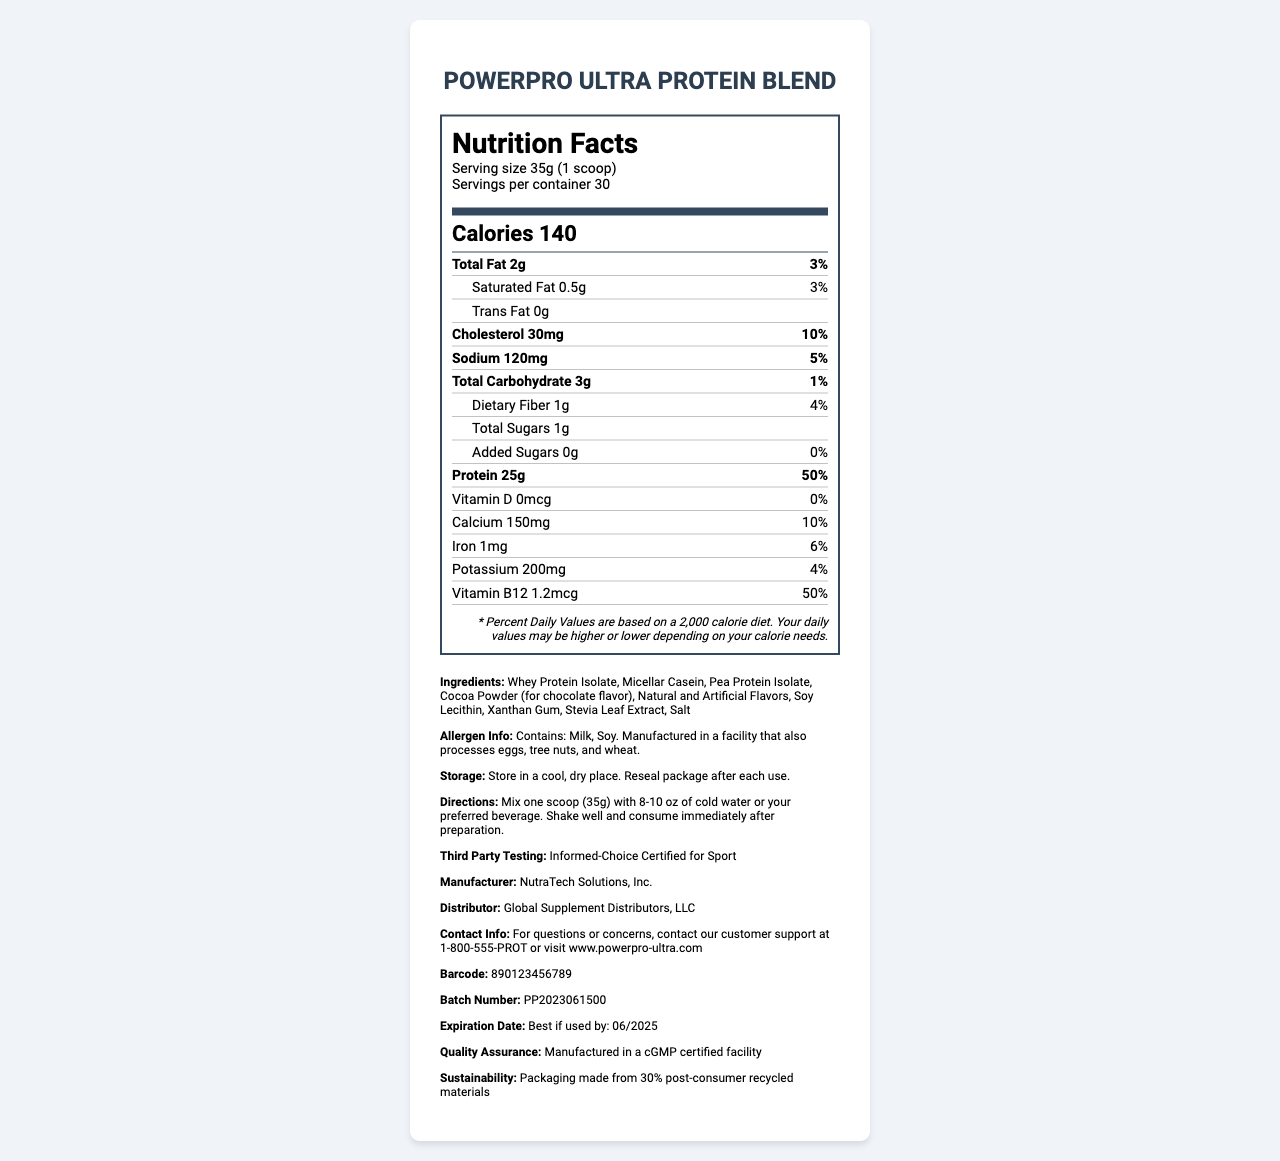what is the serving size? The serving size is specified as 35g (1 scoop) in the document.
Answer: 35g (1 scoop) how many calories are in one serving? The number of calories in one serving is listed as 140 in the document.
Answer: 140 how much protein does one serving contain? The amount of protein in one serving is specified as 25g in the document.
Answer: 25g what is the amount of total fat per serving? The amount of total fat per serving is listed as 2g in the document.
Answer: 2g what is the daily percentage value of sodium in one serving? The daily percentage value of sodium per serving is listed as 5% in the document.
Answer: 5% Which of the following is NOT an ingredient in the product? 
A. Cocoa Powder 
B. Stevia Leaf Extract 
C. Sucralose 
D. Xanthan Gum The listed ingredients are: Whey Protein Isolate, Micellar Casein, Pea Protein Isolate, Cocoa Powder, Natural and Artificial Flavors, Soy Lecithin, Xanthan Gum, Stevia Leaf Extract, and Salt.
Answer: C. Sucralose How is the product certified for quality assurance? 
I. cGMP certified facility 
II. Informed-Choice Certified for Sport 
III. FDA approved The document mentions both "Manufactured in a cGMP certified facility" and "Informed-Choice Certified for Sport."
Answer: I and II. does this product contain iron? The document mentions that the product contains 1mg of iron.
Answer: Yes summarize the key information from the nutrition facts label The summary includes the nutritional details and other product-related information, like ingredients, allergen info, storage instructions, and certifications.
Answer: The document provides detailed nutritional information about PowerPro Ultra Protein Blend, including serving size (35g), calories (140 per serving), and various macronutrients and micronutrients. It also lists ingredients, allergen information, storage instructions, and certifications. how is the product flavored? The document lists Natural and Artificial Flavors and Cocoa Powder as flavoring agents.
Answer: Natural and Artificial Flavors, Cocoa Powder (for chocolate flavor) what is the expiration date for this product? The expiration date listed in the document is "Best if used by: 06/2025."
Answer: Best if used by: 06/2025 what should customers do if they have questions about the product? The document provides customer support contact information for questions or concerns.
Answer: Contact customer support at 1-800-555-PROT or visit www.powerpro-ultra.com is vitamin D present in the product? The document lists 0mcg of Vitamin D with a daily value of 0%.
Answer: No what percentage of daily protein needs does one serving fulfill? The document states that one serving meets 50% of the daily protein value.
Answer: 50% where is the product manufactured? The manufacturer's name mentioned in the document is NutraTech Solutions, Inc.
Answer: NutraTech Solutions, Inc. how should the product be stored? The storage instructions provided are to "Store in a cool, dry place" and "Reseal package after each use."
Answer: Store in a cool, dry place. Reseal package after each use. can usage directions be found on the label? The directions are given as "Mix one scoop (35g) with 8-10 oz of cold water or your preferred beverage. Shake well and consume immediately after preparation."
Answer: Yes Is Sucralose one of the ingredients? The document does not list Sucralose, but it does mention "Natural and Artificial Flavors," which could potentially include Sucralose.
Answer: Cannot be determined 